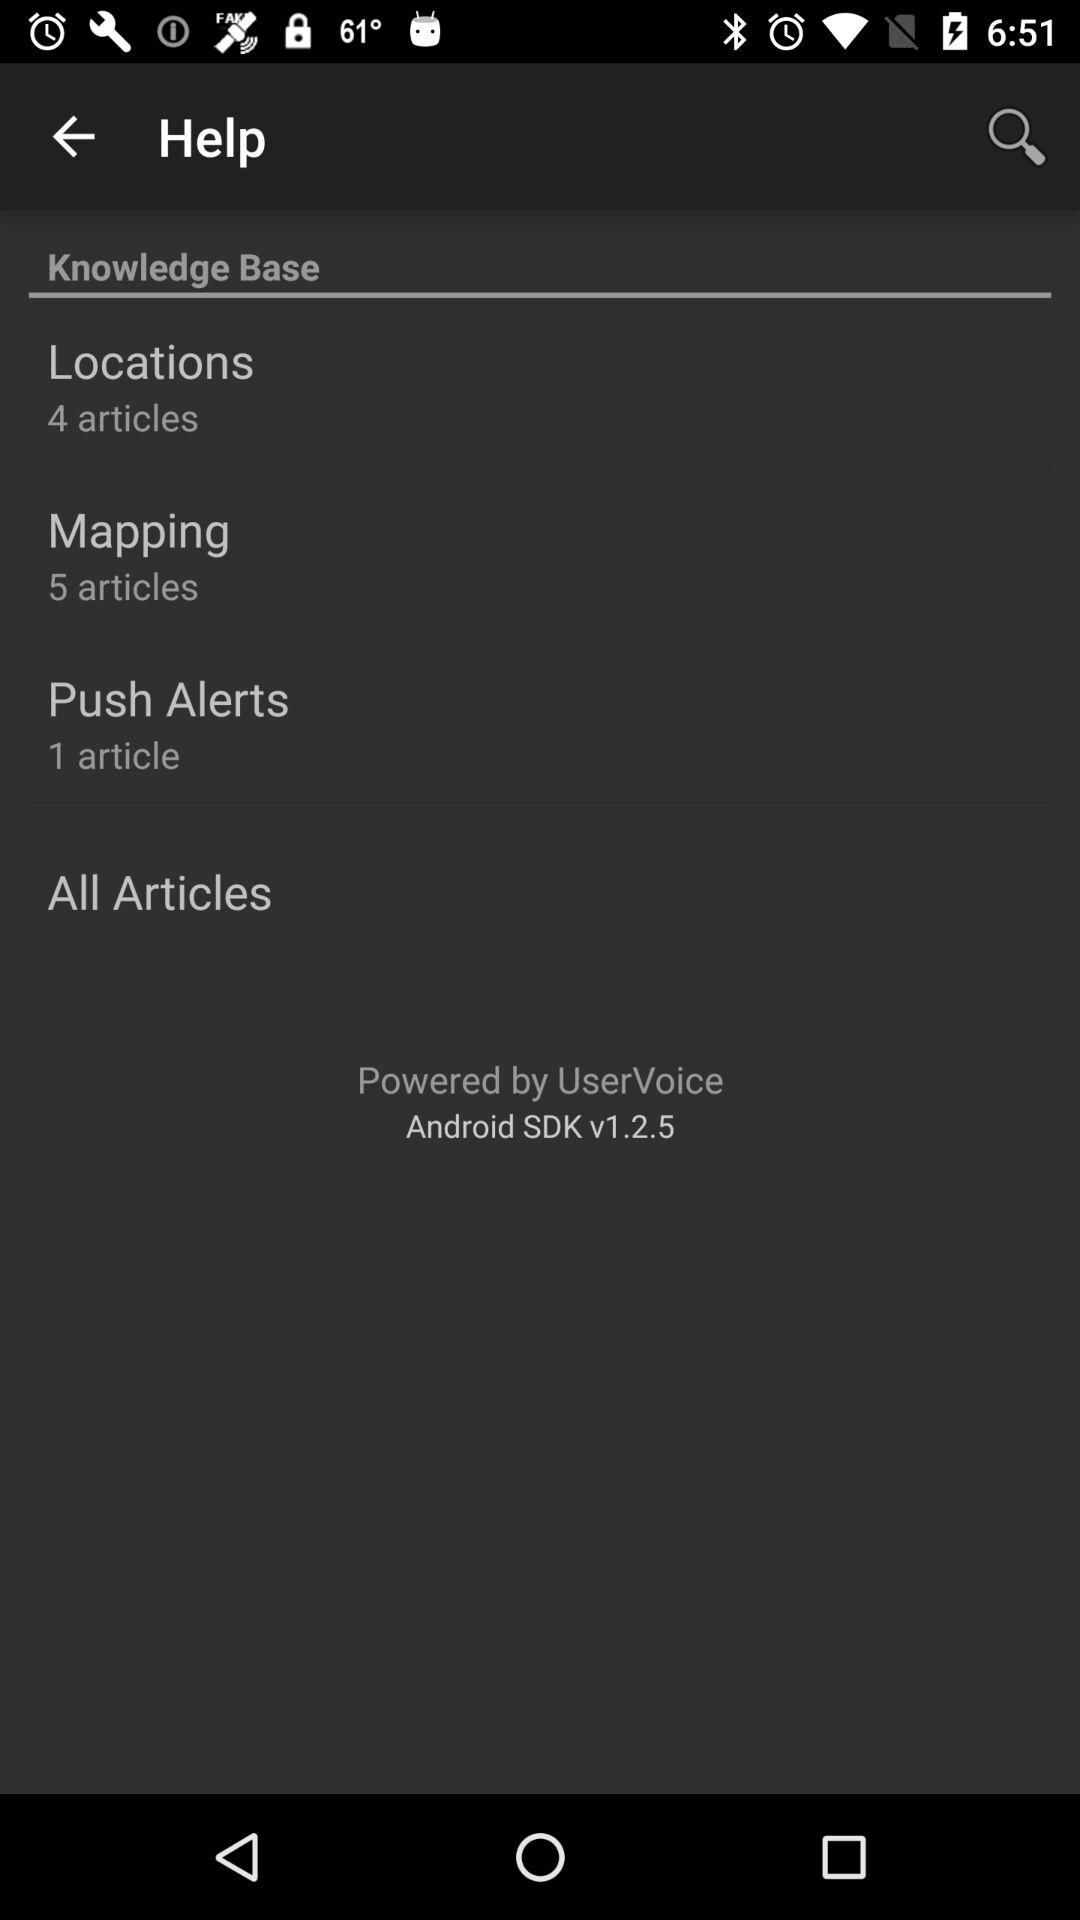What is the number of articles in "Locations"? There are 4 articles. 